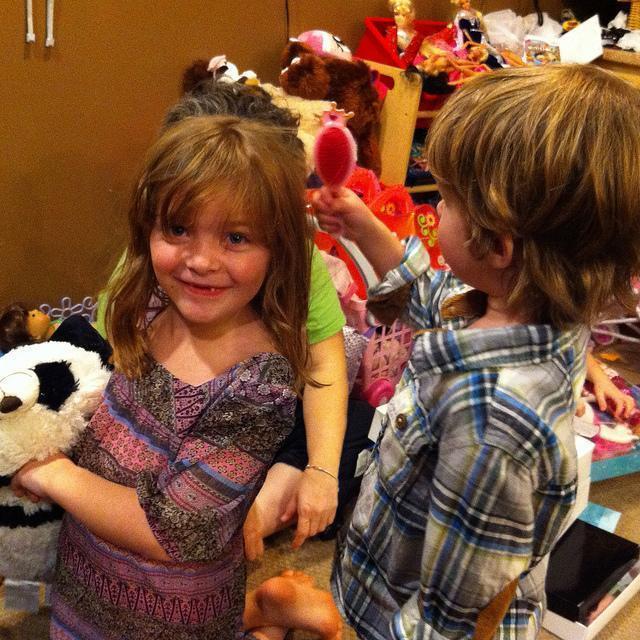What is the design called on the boy's shirt?
Make your selection from the four choices given to correctly answer the question.
Options: Polka dot, striped, flannel, plaid. Flannel. 